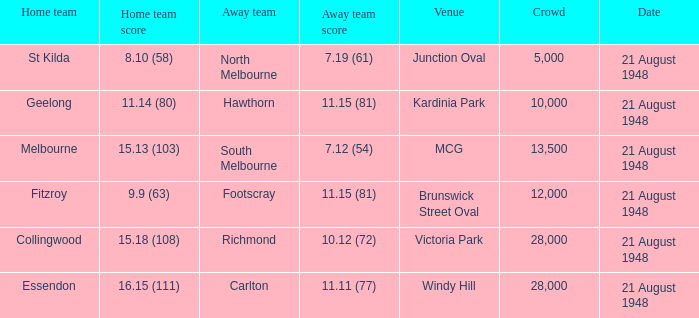Write the full table. {'header': ['Home team', 'Home team score', 'Away team', 'Away team score', 'Venue', 'Crowd', 'Date'], 'rows': [['St Kilda', '8.10 (58)', 'North Melbourne', '7.19 (61)', 'Junction Oval', '5,000', '21 August 1948'], ['Geelong', '11.14 (80)', 'Hawthorn', '11.15 (81)', 'Kardinia Park', '10,000', '21 August 1948'], ['Melbourne', '15.13 (103)', 'South Melbourne', '7.12 (54)', 'MCG', '13,500', '21 August 1948'], ['Fitzroy', '9.9 (63)', 'Footscray', '11.15 (81)', 'Brunswick Street Oval', '12,000', '21 August 1948'], ['Collingwood', '15.18 (108)', 'Richmond', '10.12 (72)', 'Victoria Park', '28,000', '21 August 1948'], ['Essendon', '16.15 (111)', 'Carlton', '11.11 (77)', 'Windy Hill', '28,000', '21 August 1948']]} When the venue is victoria park, what's the largest Crowd that attended? 28000.0. 